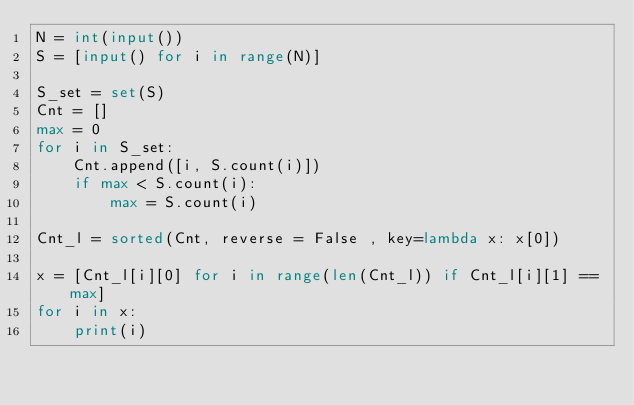Convert code to text. <code><loc_0><loc_0><loc_500><loc_500><_Python_>N = int(input())
S = [input() for i in range(N)]

S_set = set(S)
Cnt = []
max = 0
for i in S_set:
    Cnt.append([i, S.count(i)])
    if max < S.count(i):
        max = S.count(i)

Cnt_l = sorted(Cnt, reverse = False , key=lambda x: x[0])

x = [Cnt_l[i][0] for i in range(len(Cnt_l)) if Cnt_l[i][1] == max]
for i in x:
    print(i)</code> 